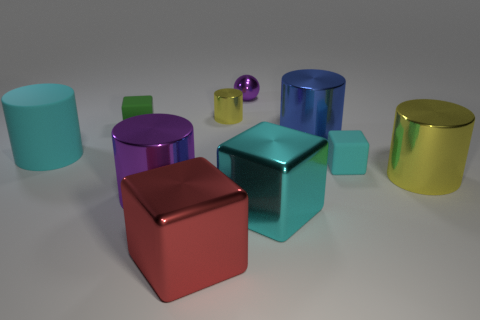Subtract all small metallic cylinders. How many cylinders are left? 4 Subtract 1 cubes. How many cubes are left? 3 Subtract all red blocks. How many blocks are left? 3 Subtract all red cylinders. Subtract all red cubes. How many cylinders are left? 5 Subtract all cubes. How many objects are left? 6 Add 3 green rubber cubes. How many green rubber cubes are left? 4 Add 6 cyan matte things. How many cyan matte things exist? 8 Subtract 0 brown balls. How many objects are left? 10 Subtract all green rubber cubes. Subtract all big red shiny blocks. How many objects are left? 8 